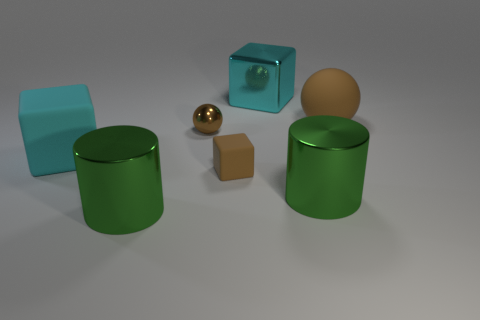Add 3 tiny green matte objects. How many objects exist? 10 Subtract all cylinders. How many objects are left? 5 Add 5 small cyan rubber cylinders. How many small cyan rubber cylinders exist? 5 Subtract 0 yellow blocks. How many objects are left? 7 Subtract all green objects. Subtract all matte balls. How many objects are left? 4 Add 3 tiny brown rubber blocks. How many tiny brown rubber blocks are left? 4 